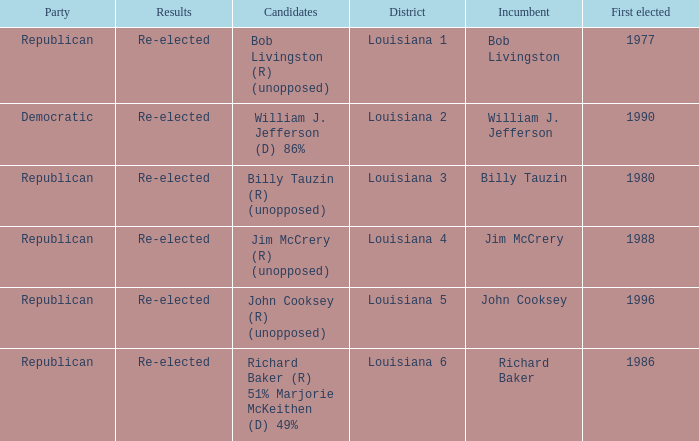What were the conclusions for incumbent jim mccrery? Re-elected. 